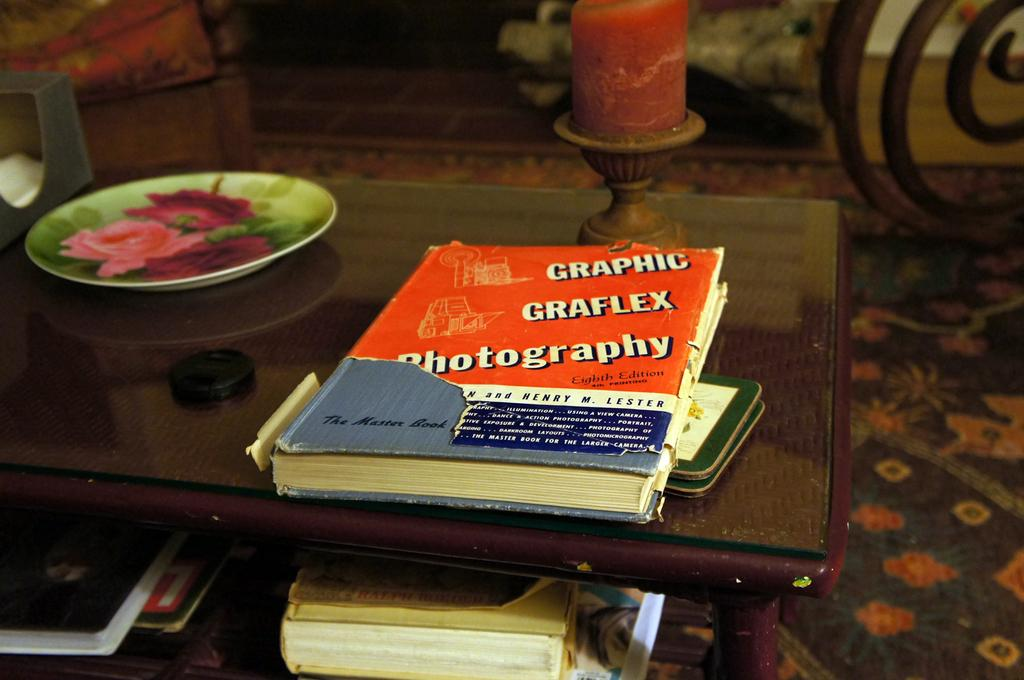<image>
Relay a brief, clear account of the picture shown. Books arranged on a coffee table include a tome on graphic photography how-to. 